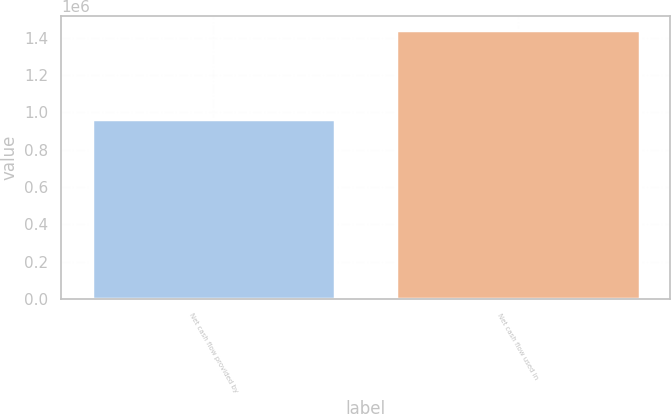Convert chart to OTSL. <chart><loc_0><loc_0><loc_500><loc_500><bar_chart><fcel>Net cash flow provided by<fcel>Net cash flow used in<nl><fcel>962909<fcel>1.44199e+06<nl></chart> 